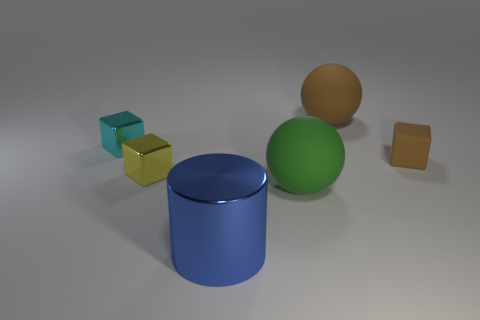Add 2 large yellow spheres. How many objects exist? 8 Subtract all balls. How many objects are left? 4 Add 3 green rubber objects. How many green rubber objects exist? 4 Subtract 1 green balls. How many objects are left? 5 Subtract all small green rubber spheres. Subtract all small yellow objects. How many objects are left? 5 Add 4 tiny yellow metallic objects. How many tiny yellow metallic objects are left? 5 